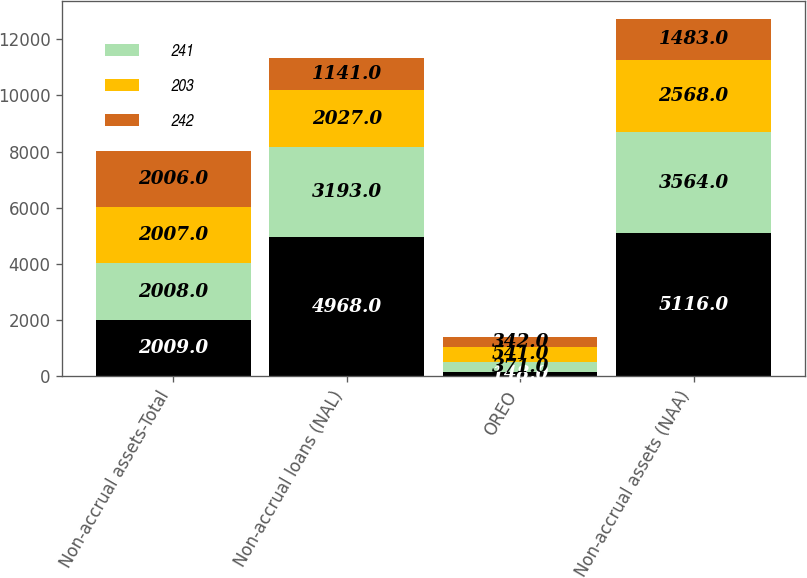<chart> <loc_0><loc_0><loc_500><loc_500><stacked_bar_chart><ecel><fcel>Non-accrual assets-Total<fcel>Non-accrual loans (NAL)<fcel>OREO<fcel>Non-accrual assets (NAA)<nl><fcel>nan<fcel>2009<fcel>4968<fcel>148<fcel>5116<nl><fcel>241<fcel>2008<fcel>3193<fcel>371<fcel>3564<nl><fcel>203<fcel>2007<fcel>2027<fcel>541<fcel>2568<nl><fcel>242<fcel>2006<fcel>1141<fcel>342<fcel>1483<nl></chart> 